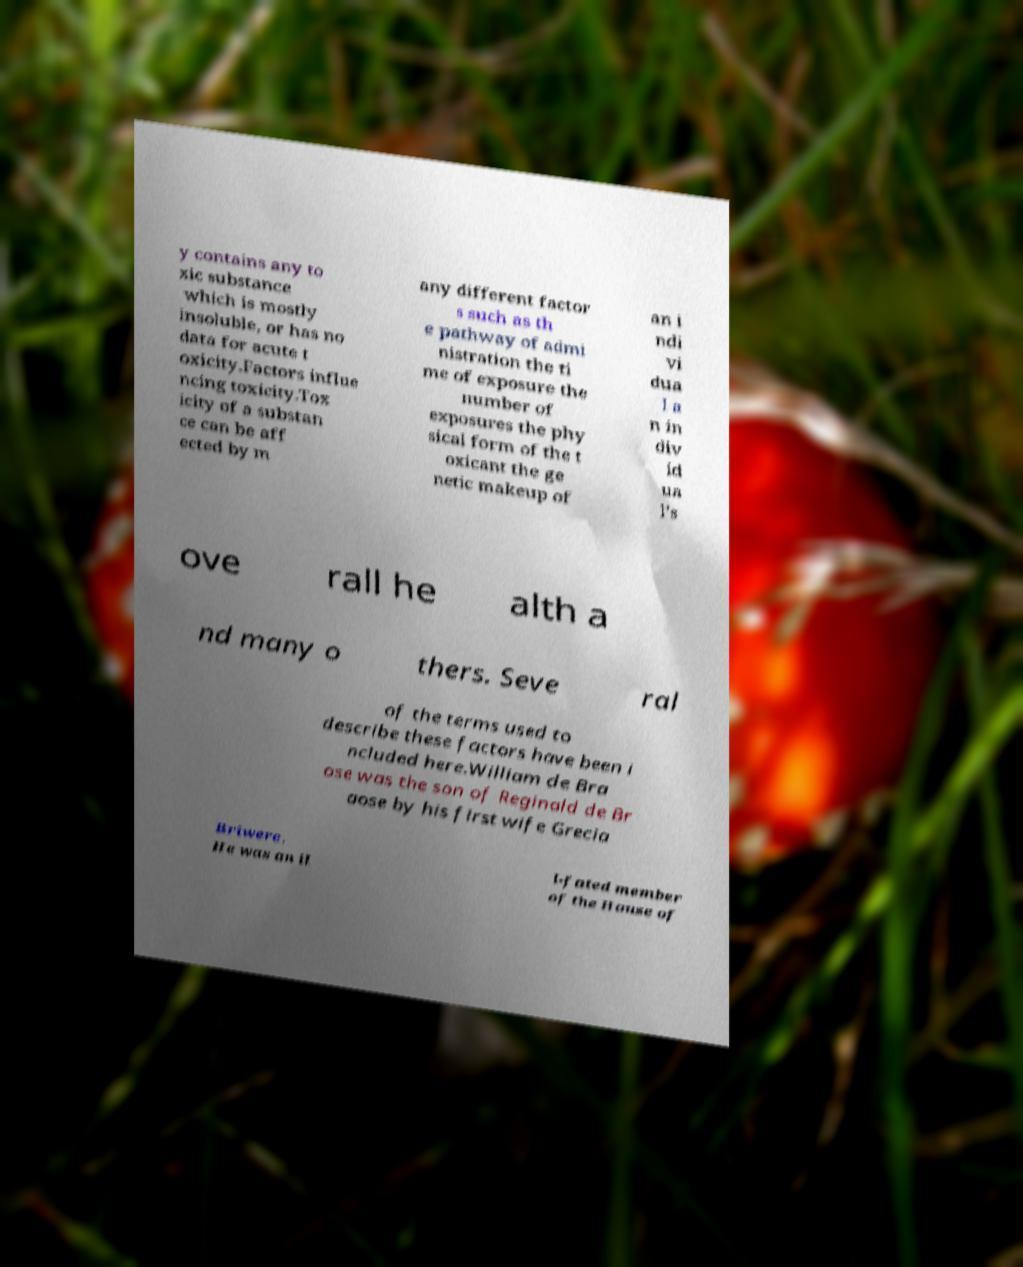What messages or text are displayed in this image? I need them in a readable, typed format. y contains any to xic substance which is mostly insoluble, or has no data for acute t oxicity.Factors influe ncing toxicity.Tox icity of a substan ce can be aff ected by m any different factor s such as th e pathway of admi nistration the ti me of exposure the number of exposures the phy sical form of the t oxicant the ge netic makeup of an i ndi vi dua l a n in div id ua l's ove rall he alth a nd many o thers. Seve ral of the terms used to describe these factors have been i ncluded here.William de Bra ose was the son of Reginald de Br aose by his first wife Grecia Briwere. He was an il l-fated member of the House of 